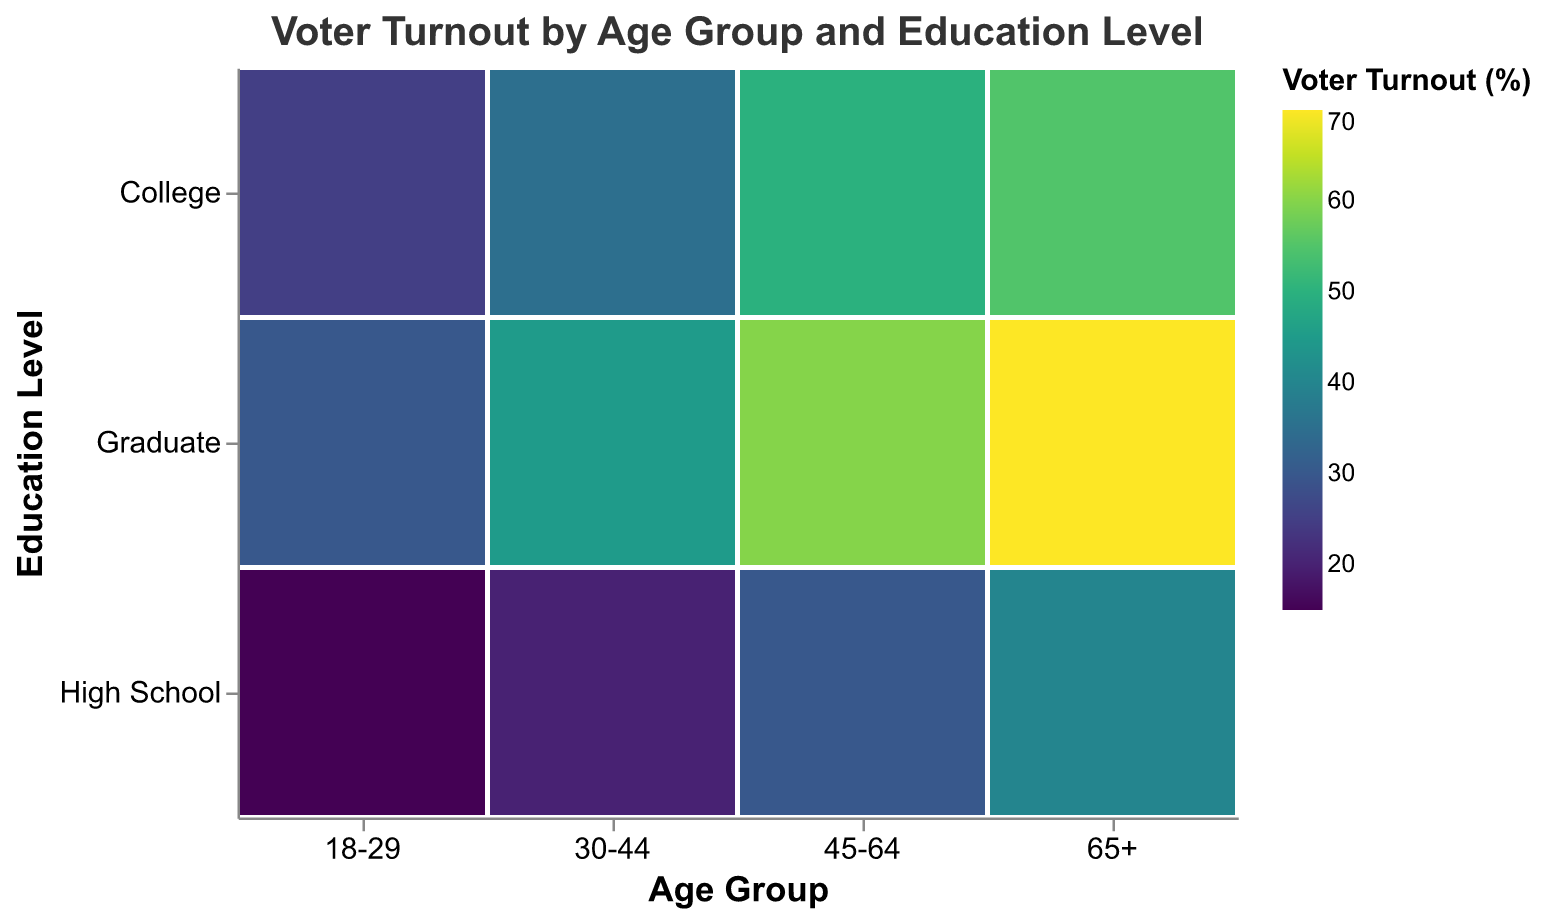What is the age group with the highest voter turnout for high school education? Observe the bars along the y-axis label "High School" and identify the tallest bar. The tallest bar is associated with the "65+" age group.
Answer: 65+ Which education level has the highest voter turnout within the 30-44 age group? Look at the three bars corresponding to "High School," "College," and "Graduate" for the age group "30-44." The bar for "Graduate" is the tallest.
Answer: Graduate What is the voter turnout for graduate-educated individuals aged 18-29? Find the intersection of "Graduate" along the y-axis and "18-29" along the x-axis. The voter turnout value is shown in the tooltip.
Answer: 30% Which age group has the lowest voter turnout for college-educated individuals? Observe the bars along the y-axis labeled "College" and identify the shortest bar. The shortest bar is associated with the "18-29" age group.
Answer: 18-29 How does the voter turnout for college-educated individuals aged 45-64 compare to those aged 18-29? Look at the bars for "College" along the y-axis and compare their heights. The bar for "45-64" is taller than the bar for "18-29."
Answer: Higher What is the average voter turnout for the 45-64 age group across all education levels? Add the voter turnout percentages for "High School," "College," and "Graduate" within the "45-64" age group: (30 + 50 + 60) = 140. Divide by 3 for the average: 140/3 = 46.67%.
Answer: 46.67% What education level has the most significant increase in voter turnout between the 18-29 and 65+ age groups? Identify the differences in voter turnout between the "18-29" and "65+" age groups for each education level: High School (40 - 15 = 25), College (55 - 25 = 30), Graduate (70 - 30 = 40). The highest increase is for "Graduate."
Answer: Graduate Which combination of age group and education level has the highest voter turnout? Identify the tallest bar in the entire mosaic plot. The tallest bar is at the intersection of "Graduate" and "65+" which shows 70%.
Answer: 65+ and Graduate 